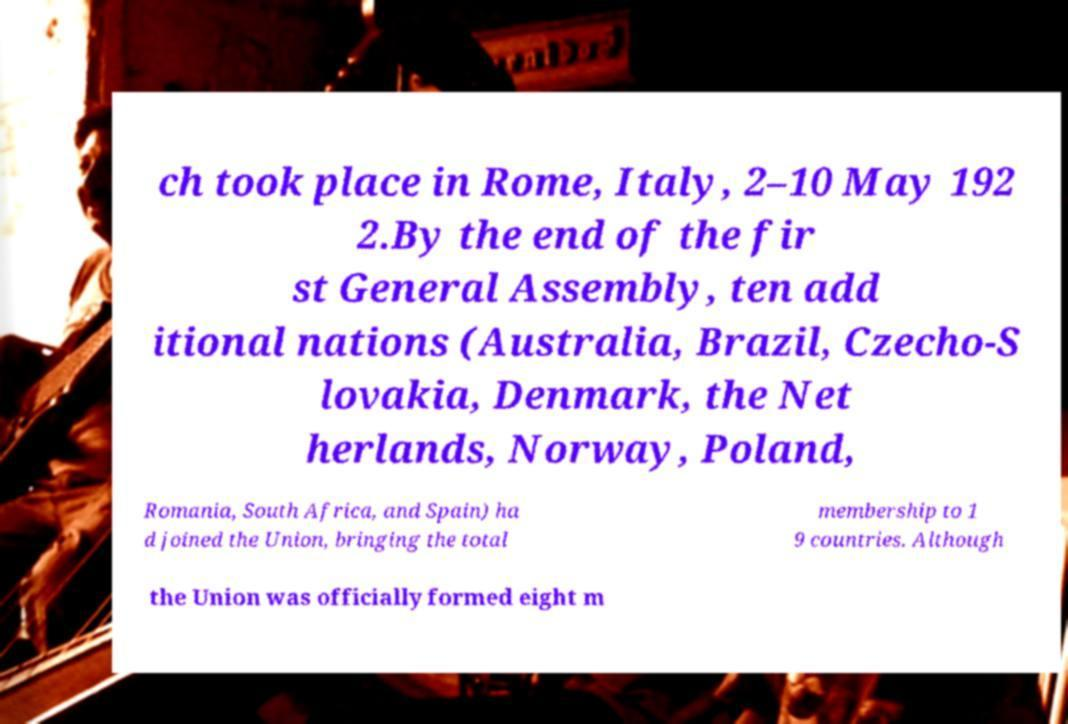What messages or text are displayed in this image? I need them in a readable, typed format. ch took place in Rome, Italy, 2–10 May 192 2.By the end of the fir st General Assembly, ten add itional nations (Australia, Brazil, Czecho-S lovakia, Denmark, the Net herlands, Norway, Poland, Romania, South Africa, and Spain) ha d joined the Union, bringing the total membership to 1 9 countries. Although the Union was officially formed eight m 